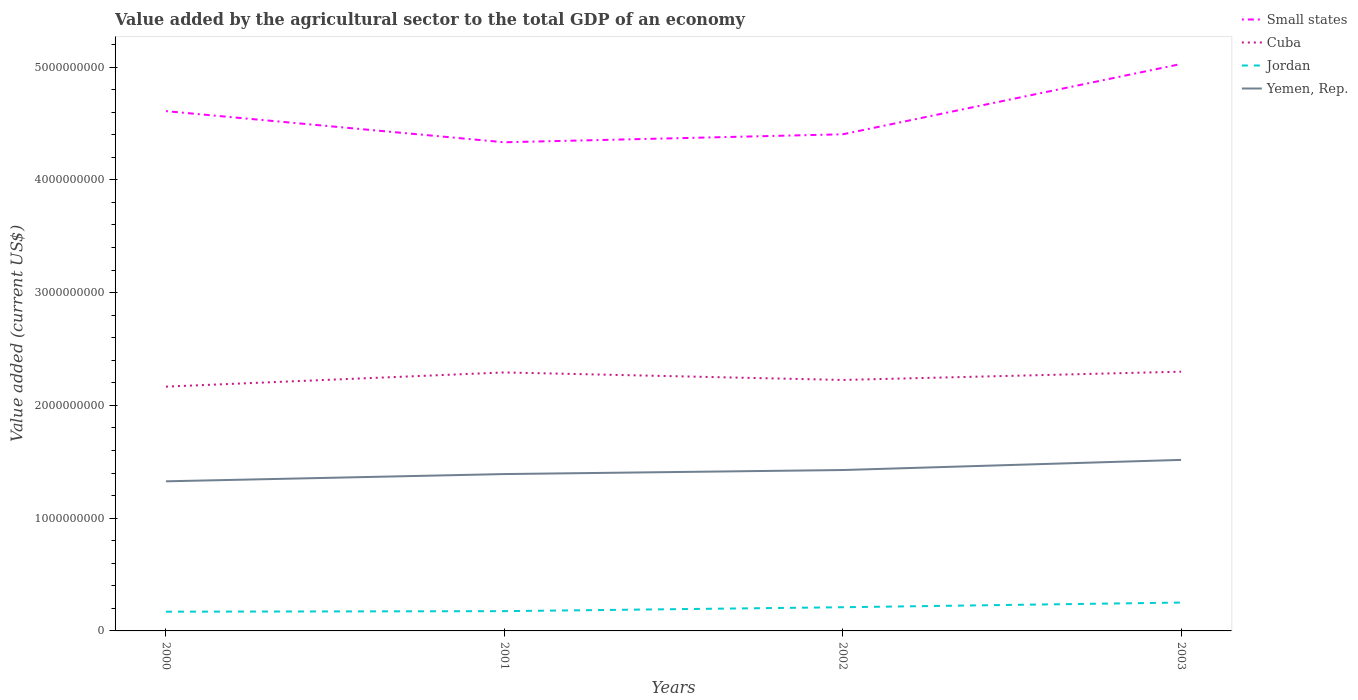How many different coloured lines are there?
Your answer should be compact. 4. Does the line corresponding to Cuba intersect with the line corresponding to Jordan?
Your answer should be very brief. No. Across all years, what is the maximum value added by the agricultural sector to the total GDP in Small states?
Provide a short and direct response. 4.33e+09. In which year was the value added by the agricultural sector to the total GDP in Jordan maximum?
Your response must be concise. 2000. What is the total value added by the agricultural sector to the total GDP in Cuba in the graph?
Your answer should be compact. -7.34e+07. What is the difference between the highest and the second highest value added by the agricultural sector to the total GDP in Cuba?
Give a very brief answer. 1.33e+08. How many lines are there?
Ensure brevity in your answer.  4. Does the graph contain any zero values?
Your response must be concise. No. How are the legend labels stacked?
Provide a succinct answer. Vertical. What is the title of the graph?
Keep it short and to the point. Value added by the agricultural sector to the total GDP of an economy. Does "Kiribati" appear as one of the legend labels in the graph?
Provide a succinct answer. No. What is the label or title of the X-axis?
Ensure brevity in your answer.  Years. What is the label or title of the Y-axis?
Your answer should be very brief. Value added (current US$). What is the Value added (current US$) in Small states in 2000?
Your answer should be compact. 4.61e+09. What is the Value added (current US$) of Cuba in 2000?
Ensure brevity in your answer.  2.17e+09. What is the Value added (current US$) in Jordan in 2000?
Make the answer very short. 1.71e+08. What is the Value added (current US$) in Yemen, Rep. in 2000?
Your response must be concise. 1.33e+09. What is the Value added (current US$) in Small states in 2001?
Ensure brevity in your answer.  4.33e+09. What is the Value added (current US$) in Cuba in 2001?
Ensure brevity in your answer.  2.29e+09. What is the Value added (current US$) of Jordan in 2001?
Provide a succinct answer. 1.75e+08. What is the Value added (current US$) of Yemen, Rep. in 2001?
Make the answer very short. 1.39e+09. What is the Value added (current US$) of Small states in 2002?
Your response must be concise. 4.40e+09. What is the Value added (current US$) in Cuba in 2002?
Ensure brevity in your answer.  2.23e+09. What is the Value added (current US$) in Jordan in 2002?
Your answer should be compact. 2.10e+08. What is the Value added (current US$) of Yemen, Rep. in 2002?
Make the answer very short. 1.43e+09. What is the Value added (current US$) in Small states in 2003?
Offer a terse response. 5.03e+09. What is the Value added (current US$) in Cuba in 2003?
Make the answer very short. 2.30e+09. What is the Value added (current US$) of Jordan in 2003?
Your answer should be very brief. 2.52e+08. What is the Value added (current US$) of Yemen, Rep. in 2003?
Provide a short and direct response. 1.52e+09. Across all years, what is the maximum Value added (current US$) in Small states?
Give a very brief answer. 5.03e+09. Across all years, what is the maximum Value added (current US$) of Cuba?
Make the answer very short. 2.30e+09. Across all years, what is the maximum Value added (current US$) in Jordan?
Make the answer very short. 2.52e+08. Across all years, what is the maximum Value added (current US$) of Yemen, Rep.?
Make the answer very short. 1.52e+09. Across all years, what is the minimum Value added (current US$) of Small states?
Your answer should be compact. 4.33e+09. Across all years, what is the minimum Value added (current US$) in Cuba?
Your answer should be compact. 2.17e+09. Across all years, what is the minimum Value added (current US$) of Jordan?
Offer a terse response. 1.71e+08. Across all years, what is the minimum Value added (current US$) in Yemen, Rep.?
Offer a terse response. 1.33e+09. What is the total Value added (current US$) of Small states in the graph?
Offer a very short reply. 1.84e+1. What is the total Value added (current US$) in Cuba in the graph?
Provide a short and direct response. 8.98e+09. What is the total Value added (current US$) in Jordan in the graph?
Ensure brevity in your answer.  8.07e+08. What is the total Value added (current US$) in Yemen, Rep. in the graph?
Offer a terse response. 5.66e+09. What is the difference between the Value added (current US$) of Small states in 2000 and that in 2001?
Your answer should be very brief. 2.76e+08. What is the difference between the Value added (current US$) in Cuba in 2000 and that in 2001?
Offer a very short reply. -1.26e+08. What is the difference between the Value added (current US$) in Jordan in 2000 and that in 2001?
Your answer should be compact. -4.83e+06. What is the difference between the Value added (current US$) of Yemen, Rep. in 2000 and that in 2001?
Give a very brief answer. -6.42e+07. What is the difference between the Value added (current US$) of Small states in 2000 and that in 2002?
Your answer should be compact. 2.05e+08. What is the difference between the Value added (current US$) of Cuba in 2000 and that in 2002?
Your response must be concise. -5.92e+07. What is the difference between the Value added (current US$) of Jordan in 2000 and that in 2002?
Make the answer very short. -3.95e+07. What is the difference between the Value added (current US$) of Yemen, Rep. in 2000 and that in 2002?
Keep it short and to the point. -1.00e+08. What is the difference between the Value added (current US$) of Small states in 2000 and that in 2003?
Your response must be concise. -4.18e+08. What is the difference between the Value added (current US$) of Cuba in 2000 and that in 2003?
Ensure brevity in your answer.  -1.33e+08. What is the difference between the Value added (current US$) in Jordan in 2000 and that in 2003?
Provide a succinct answer. -8.10e+07. What is the difference between the Value added (current US$) in Yemen, Rep. in 2000 and that in 2003?
Provide a succinct answer. -1.90e+08. What is the difference between the Value added (current US$) in Small states in 2001 and that in 2002?
Provide a short and direct response. -7.08e+07. What is the difference between the Value added (current US$) in Cuba in 2001 and that in 2002?
Offer a very short reply. 6.67e+07. What is the difference between the Value added (current US$) of Jordan in 2001 and that in 2002?
Your answer should be very brief. -3.47e+07. What is the difference between the Value added (current US$) of Yemen, Rep. in 2001 and that in 2002?
Offer a very short reply. -3.58e+07. What is the difference between the Value added (current US$) in Small states in 2001 and that in 2003?
Your response must be concise. -6.94e+08. What is the difference between the Value added (current US$) in Cuba in 2001 and that in 2003?
Your answer should be compact. -6.70e+06. What is the difference between the Value added (current US$) of Jordan in 2001 and that in 2003?
Offer a terse response. -7.62e+07. What is the difference between the Value added (current US$) of Yemen, Rep. in 2001 and that in 2003?
Offer a terse response. -1.26e+08. What is the difference between the Value added (current US$) of Small states in 2002 and that in 2003?
Make the answer very short. -6.24e+08. What is the difference between the Value added (current US$) of Cuba in 2002 and that in 2003?
Ensure brevity in your answer.  -7.34e+07. What is the difference between the Value added (current US$) of Jordan in 2002 and that in 2003?
Offer a very short reply. -4.15e+07. What is the difference between the Value added (current US$) of Yemen, Rep. in 2002 and that in 2003?
Offer a terse response. -8.99e+07. What is the difference between the Value added (current US$) of Small states in 2000 and the Value added (current US$) of Cuba in 2001?
Provide a short and direct response. 2.32e+09. What is the difference between the Value added (current US$) in Small states in 2000 and the Value added (current US$) in Jordan in 2001?
Your response must be concise. 4.43e+09. What is the difference between the Value added (current US$) of Small states in 2000 and the Value added (current US$) of Yemen, Rep. in 2001?
Offer a very short reply. 3.22e+09. What is the difference between the Value added (current US$) of Cuba in 2000 and the Value added (current US$) of Jordan in 2001?
Your answer should be very brief. 1.99e+09. What is the difference between the Value added (current US$) of Cuba in 2000 and the Value added (current US$) of Yemen, Rep. in 2001?
Ensure brevity in your answer.  7.75e+08. What is the difference between the Value added (current US$) in Jordan in 2000 and the Value added (current US$) in Yemen, Rep. in 2001?
Your answer should be compact. -1.22e+09. What is the difference between the Value added (current US$) in Small states in 2000 and the Value added (current US$) in Cuba in 2002?
Your response must be concise. 2.38e+09. What is the difference between the Value added (current US$) in Small states in 2000 and the Value added (current US$) in Jordan in 2002?
Your answer should be compact. 4.40e+09. What is the difference between the Value added (current US$) of Small states in 2000 and the Value added (current US$) of Yemen, Rep. in 2002?
Give a very brief answer. 3.18e+09. What is the difference between the Value added (current US$) of Cuba in 2000 and the Value added (current US$) of Jordan in 2002?
Offer a terse response. 1.96e+09. What is the difference between the Value added (current US$) in Cuba in 2000 and the Value added (current US$) in Yemen, Rep. in 2002?
Provide a short and direct response. 7.40e+08. What is the difference between the Value added (current US$) in Jordan in 2000 and the Value added (current US$) in Yemen, Rep. in 2002?
Provide a succinct answer. -1.26e+09. What is the difference between the Value added (current US$) in Small states in 2000 and the Value added (current US$) in Cuba in 2003?
Offer a terse response. 2.31e+09. What is the difference between the Value added (current US$) of Small states in 2000 and the Value added (current US$) of Jordan in 2003?
Keep it short and to the point. 4.36e+09. What is the difference between the Value added (current US$) in Small states in 2000 and the Value added (current US$) in Yemen, Rep. in 2003?
Give a very brief answer. 3.09e+09. What is the difference between the Value added (current US$) of Cuba in 2000 and the Value added (current US$) of Jordan in 2003?
Make the answer very short. 1.91e+09. What is the difference between the Value added (current US$) of Cuba in 2000 and the Value added (current US$) of Yemen, Rep. in 2003?
Give a very brief answer. 6.50e+08. What is the difference between the Value added (current US$) of Jordan in 2000 and the Value added (current US$) of Yemen, Rep. in 2003?
Provide a succinct answer. -1.35e+09. What is the difference between the Value added (current US$) in Small states in 2001 and the Value added (current US$) in Cuba in 2002?
Your response must be concise. 2.11e+09. What is the difference between the Value added (current US$) of Small states in 2001 and the Value added (current US$) of Jordan in 2002?
Provide a short and direct response. 4.12e+09. What is the difference between the Value added (current US$) of Small states in 2001 and the Value added (current US$) of Yemen, Rep. in 2002?
Offer a very short reply. 2.91e+09. What is the difference between the Value added (current US$) in Cuba in 2001 and the Value added (current US$) in Jordan in 2002?
Offer a very short reply. 2.08e+09. What is the difference between the Value added (current US$) of Cuba in 2001 and the Value added (current US$) of Yemen, Rep. in 2002?
Keep it short and to the point. 8.65e+08. What is the difference between the Value added (current US$) of Jordan in 2001 and the Value added (current US$) of Yemen, Rep. in 2002?
Your response must be concise. -1.25e+09. What is the difference between the Value added (current US$) in Small states in 2001 and the Value added (current US$) in Cuba in 2003?
Offer a very short reply. 2.03e+09. What is the difference between the Value added (current US$) of Small states in 2001 and the Value added (current US$) of Jordan in 2003?
Your response must be concise. 4.08e+09. What is the difference between the Value added (current US$) of Small states in 2001 and the Value added (current US$) of Yemen, Rep. in 2003?
Make the answer very short. 2.82e+09. What is the difference between the Value added (current US$) in Cuba in 2001 and the Value added (current US$) in Jordan in 2003?
Ensure brevity in your answer.  2.04e+09. What is the difference between the Value added (current US$) of Cuba in 2001 and the Value added (current US$) of Yemen, Rep. in 2003?
Offer a very short reply. 7.76e+08. What is the difference between the Value added (current US$) of Jordan in 2001 and the Value added (current US$) of Yemen, Rep. in 2003?
Your answer should be very brief. -1.34e+09. What is the difference between the Value added (current US$) in Small states in 2002 and the Value added (current US$) in Cuba in 2003?
Offer a terse response. 2.11e+09. What is the difference between the Value added (current US$) of Small states in 2002 and the Value added (current US$) of Jordan in 2003?
Ensure brevity in your answer.  4.15e+09. What is the difference between the Value added (current US$) of Small states in 2002 and the Value added (current US$) of Yemen, Rep. in 2003?
Ensure brevity in your answer.  2.89e+09. What is the difference between the Value added (current US$) in Cuba in 2002 and the Value added (current US$) in Jordan in 2003?
Offer a very short reply. 1.97e+09. What is the difference between the Value added (current US$) of Cuba in 2002 and the Value added (current US$) of Yemen, Rep. in 2003?
Offer a terse response. 7.09e+08. What is the difference between the Value added (current US$) of Jordan in 2002 and the Value added (current US$) of Yemen, Rep. in 2003?
Give a very brief answer. -1.31e+09. What is the average Value added (current US$) of Small states per year?
Your response must be concise. 4.59e+09. What is the average Value added (current US$) in Cuba per year?
Ensure brevity in your answer.  2.25e+09. What is the average Value added (current US$) of Jordan per year?
Make the answer very short. 2.02e+08. What is the average Value added (current US$) in Yemen, Rep. per year?
Give a very brief answer. 1.42e+09. In the year 2000, what is the difference between the Value added (current US$) of Small states and Value added (current US$) of Cuba?
Provide a short and direct response. 2.44e+09. In the year 2000, what is the difference between the Value added (current US$) of Small states and Value added (current US$) of Jordan?
Make the answer very short. 4.44e+09. In the year 2000, what is the difference between the Value added (current US$) of Small states and Value added (current US$) of Yemen, Rep.?
Ensure brevity in your answer.  3.28e+09. In the year 2000, what is the difference between the Value added (current US$) of Cuba and Value added (current US$) of Jordan?
Provide a succinct answer. 2.00e+09. In the year 2000, what is the difference between the Value added (current US$) in Cuba and Value added (current US$) in Yemen, Rep.?
Make the answer very short. 8.40e+08. In the year 2000, what is the difference between the Value added (current US$) of Jordan and Value added (current US$) of Yemen, Rep.?
Provide a succinct answer. -1.16e+09. In the year 2001, what is the difference between the Value added (current US$) of Small states and Value added (current US$) of Cuba?
Your answer should be compact. 2.04e+09. In the year 2001, what is the difference between the Value added (current US$) in Small states and Value added (current US$) in Jordan?
Your answer should be very brief. 4.16e+09. In the year 2001, what is the difference between the Value added (current US$) of Small states and Value added (current US$) of Yemen, Rep.?
Provide a short and direct response. 2.94e+09. In the year 2001, what is the difference between the Value added (current US$) of Cuba and Value added (current US$) of Jordan?
Provide a succinct answer. 2.12e+09. In the year 2001, what is the difference between the Value added (current US$) in Cuba and Value added (current US$) in Yemen, Rep.?
Your answer should be compact. 9.01e+08. In the year 2001, what is the difference between the Value added (current US$) of Jordan and Value added (current US$) of Yemen, Rep.?
Make the answer very short. -1.22e+09. In the year 2002, what is the difference between the Value added (current US$) in Small states and Value added (current US$) in Cuba?
Offer a terse response. 2.18e+09. In the year 2002, what is the difference between the Value added (current US$) in Small states and Value added (current US$) in Jordan?
Your answer should be very brief. 4.19e+09. In the year 2002, what is the difference between the Value added (current US$) in Small states and Value added (current US$) in Yemen, Rep.?
Ensure brevity in your answer.  2.98e+09. In the year 2002, what is the difference between the Value added (current US$) of Cuba and Value added (current US$) of Jordan?
Your response must be concise. 2.02e+09. In the year 2002, what is the difference between the Value added (current US$) in Cuba and Value added (current US$) in Yemen, Rep.?
Your answer should be very brief. 7.99e+08. In the year 2002, what is the difference between the Value added (current US$) of Jordan and Value added (current US$) of Yemen, Rep.?
Keep it short and to the point. -1.22e+09. In the year 2003, what is the difference between the Value added (current US$) of Small states and Value added (current US$) of Cuba?
Offer a very short reply. 2.73e+09. In the year 2003, what is the difference between the Value added (current US$) in Small states and Value added (current US$) in Jordan?
Offer a very short reply. 4.78e+09. In the year 2003, what is the difference between the Value added (current US$) of Small states and Value added (current US$) of Yemen, Rep.?
Your response must be concise. 3.51e+09. In the year 2003, what is the difference between the Value added (current US$) in Cuba and Value added (current US$) in Jordan?
Your response must be concise. 2.05e+09. In the year 2003, what is the difference between the Value added (current US$) in Cuba and Value added (current US$) in Yemen, Rep.?
Provide a short and direct response. 7.82e+08. In the year 2003, what is the difference between the Value added (current US$) in Jordan and Value added (current US$) in Yemen, Rep.?
Ensure brevity in your answer.  -1.27e+09. What is the ratio of the Value added (current US$) in Small states in 2000 to that in 2001?
Your answer should be very brief. 1.06. What is the ratio of the Value added (current US$) of Cuba in 2000 to that in 2001?
Ensure brevity in your answer.  0.95. What is the ratio of the Value added (current US$) of Jordan in 2000 to that in 2001?
Your answer should be very brief. 0.97. What is the ratio of the Value added (current US$) of Yemen, Rep. in 2000 to that in 2001?
Offer a very short reply. 0.95. What is the ratio of the Value added (current US$) of Small states in 2000 to that in 2002?
Offer a very short reply. 1.05. What is the ratio of the Value added (current US$) in Cuba in 2000 to that in 2002?
Provide a succinct answer. 0.97. What is the ratio of the Value added (current US$) in Jordan in 2000 to that in 2002?
Your response must be concise. 0.81. What is the ratio of the Value added (current US$) in Yemen, Rep. in 2000 to that in 2002?
Offer a very short reply. 0.93. What is the ratio of the Value added (current US$) of Small states in 2000 to that in 2003?
Give a very brief answer. 0.92. What is the ratio of the Value added (current US$) in Cuba in 2000 to that in 2003?
Make the answer very short. 0.94. What is the ratio of the Value added (current US$) of Jordan in 2000 to that in 2003?
Your response must be concise. 0.68. What is the ratio of the Value added (current US$) of Yemen, Rep. in 2000 to that in 2003?
Make the answer very short. 0.87. What is the ratio of the Value added (current US$) of Small states in 2001 to that in 2002?
Make the answer very short. 0.98. What is the ratio of the Value added (current US$) of Jordan in 2001 to that in 2002?
Give a very brief answer. 0.83. What is the ratio of the Value added (current US$) in Yemen, Rep. in 2001 to that in 2002?
Provide a succinct answer. 0.97. What is the ratio of the Value added (current US$) in Small states in 2001 to that in 2003?
Offer a very short reply. 0.86. What is the ratio of the Value added (current US$) in Jordan in 2001 to that in 2003?
Offer a terse response. 0.7. What is the ratio of the Value added (current US$) of Yemen, Rep. in 2001 to that in 2003?
Provide a succinct answer. 0.92. What is the ratio of the Value added (current US$) in Small states in 2002 to that in 2003?
Offer a very short reply. 0.88. What is the ratio of the Value added (current US$) in Cuba in 2002 to that in 2003?
Provide a succinct answer. 0.97. What is the ratio of the Value added (current US$) of Jordan in 2002 to that in 2003?
Your response must be concise. 0.84. What is the ratio of the Value added (current US$) of Yemen, Rep. in 2002 to that in 2003?
Your answer should be very brief. 0.94. What is the difference between the highest and the second highest Value added (current US$) in Small states?
Your response must be concise. 4.18e+08. What is the difference between the highest and the second highest Value added (current US$) of Cuba?
Your response must be concise. 6.70e+06. What is the difference between the highest and the second highest Value added (current US$) of Jordan?
Your answer should be compact. 4.15e+07. What is the difference between the highest and the second highest Value added (current US$) of Yemen, Rep.?
Keep it short and to the point. 8.99e+07. What is the difference between the highest and the lowest Value added (current US$) in Small states?
Your answer should be compact. 6.94e+08. What is the difference between the highest and the lowest Value added (current US$) in Cuba?
Ensure brevity in your answer.  1.33e+08. What is the difference between the highest and the lowest Value added (current US$) of Jordan?
Keep it short and to the point. 8.10e+07. What is the difference between the highest and the lowest Value added (current US$) of Yemen, Rep.?
Your answer should be very brief. 1.90e+08. 